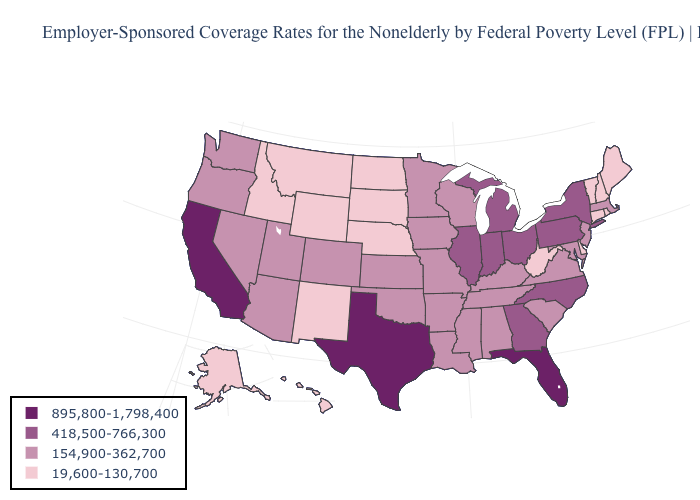What is the value of Illinois?
Concise answer only. 418,500-766,300. Does the map have missing data?
Be succinct. No. Name the states that have a value in the range 19,600-130,700?
Quick response, please. Alaska, Connecticut, Delaware, Hawaii, Idaho, Maine, Montana, Nebraska, New Hampshire, New Mexico, North Dakota, Rhode Island, South Dakota, Vermont, West Virginia, Wyoming. What is the value of Montana?
Keep it brief. 19,600-130,700. Does Wyoming have the lowest value in the West?
Short answer required. Yes. What is the lowest value in the USA?
Answer briefly. 19,600-130,700. Among the states that border Kentucky , does Tennessee have the lowest value?
Give a very brief answer. No. Does Alaska have the lowest value in the USA?
Be succinct. Yes. What is the value of New Hampshire?
Be succinct. 19,600-130,700. Name the states that have a value in the range 418,500-766,300?
Answer briefly. Georgia, Illinois, Indiana, Michigan, New York, North Carolina, Ohio, Pennsylvania. What is the lowest value in the USA?
Answer briefly. 19,600-130,700. Name the states that have a value in the range 895,800-1,798,400?
Answer briefly. California, Florida, Texas. Does Georgia have a higher value than Kentucky?
Answer briefly. Yes. Does Utah have the lowest value in the West?
Write a very short answer. No. 